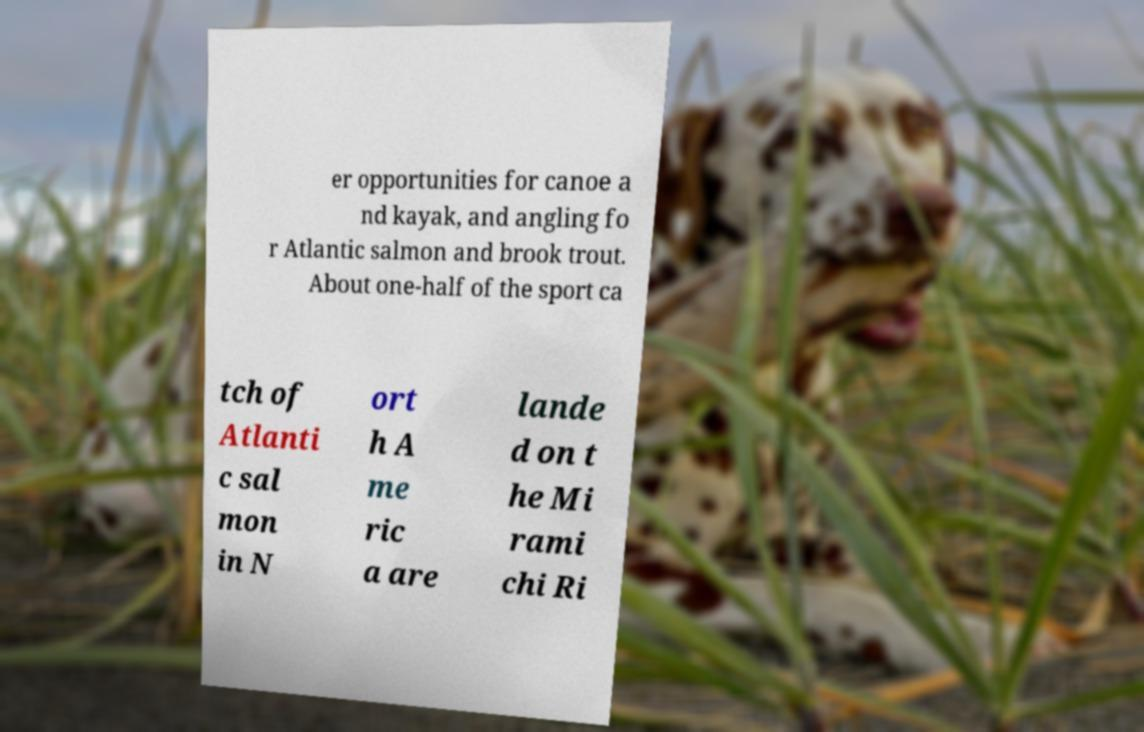For documentation purposes, I need the text within this image transcribed. Could you provide that? er opportunities for canoe a nd kayak, and angling fo r Atlantic salmon and brook trout. About one-half of the sport ca tch of Atlanti c sal mon in N ort h A me ric a are lande d on t he Mi rami chi Ri 